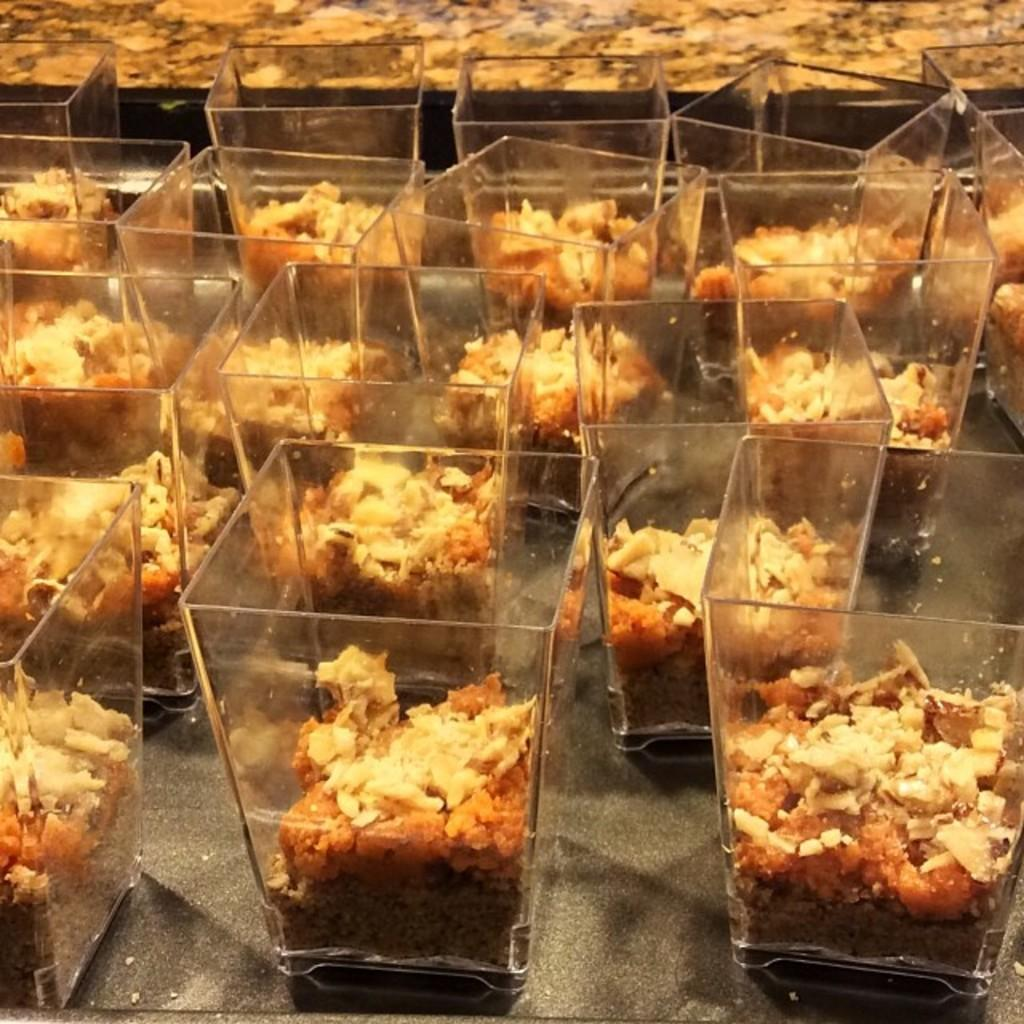What type of containers are present in the image? There are glass bowls in the image. What is inside the glass bowls? The bowls contain food. Can you describe the appearance of the food? The food has cream and brown colors. Is there any food visible outside of the glass bowls? Yes, there is food visible in the background of the image. Can you tell me how many scarecrows are standing in the background of the image? There are no scarecrows present in the image; it only features glass bowls with food. 